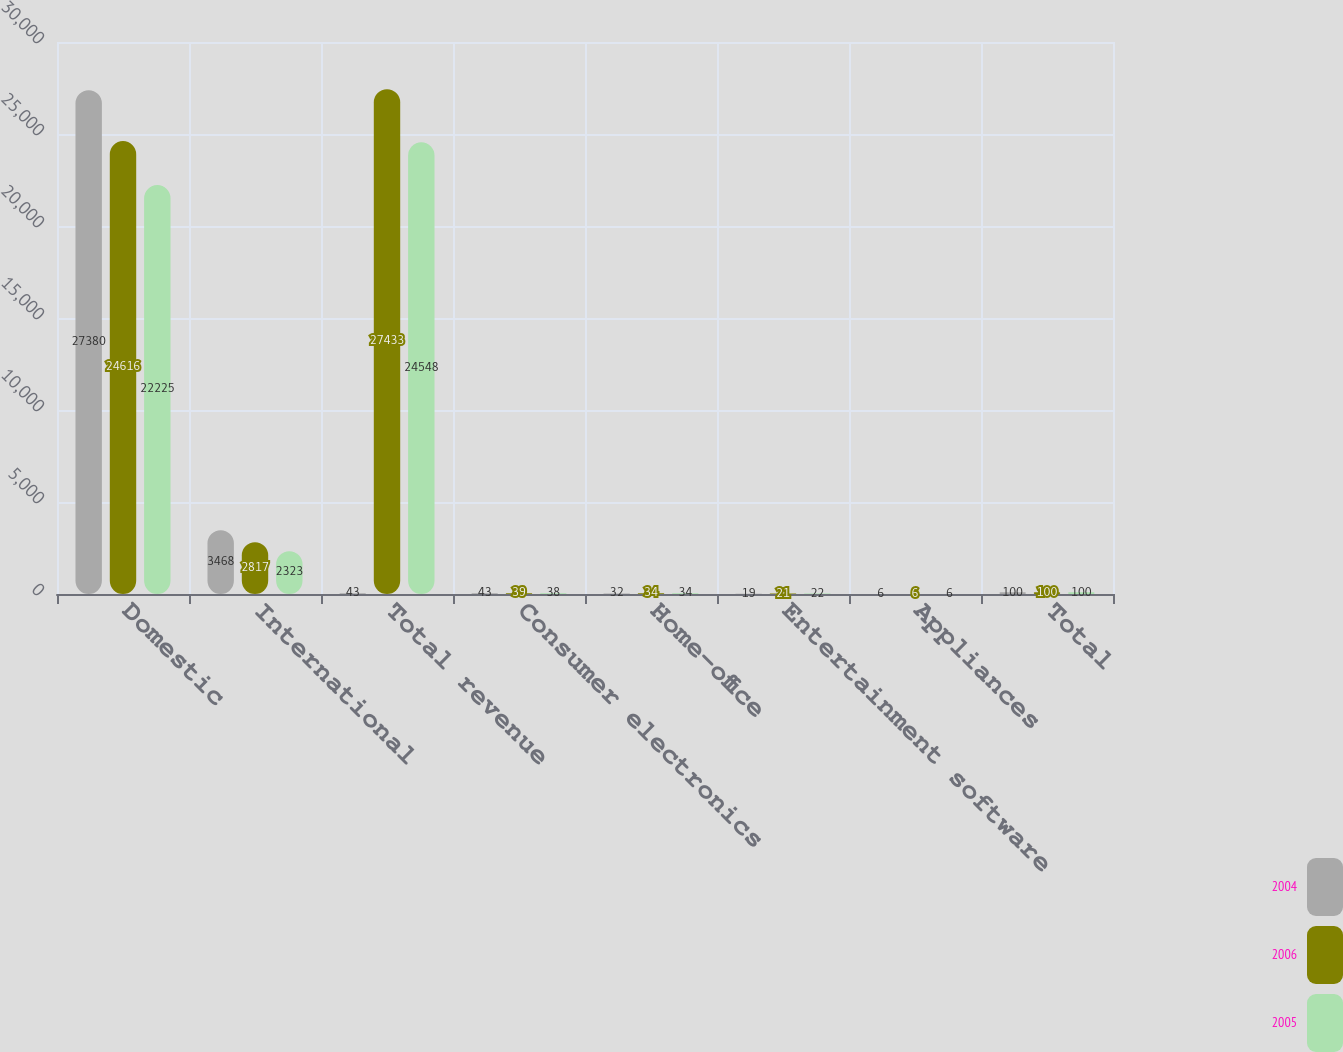Convert chart. <chart><loc_0><loc_0><loc_500><loc_500><stacked_bar_chart><ecel><fcel>Domestic<fcel>International<fcel>Total revenue<fcel>Consumer electronics<fcel>Home-office<fcel>Entertainment software<fcel>Appliances<fcel>Total<nl><fcel>2004<fcel>27380<fcel>3468<fcel>43<fcel>43<fcel>32<fcel>19<fcel>6<fcel>100<nl><fcel>2006<fcel>24616<fcel>2817<fcel>27433<fcel>39<fcel>34<fcel>21<fcel>6<fcel>100<nl><fcel>2005<fcel>22225<fcel>2323<fcel>24548<fcel>38<fcel>34<fcel>22<fcel>6<fcel>100<nl></chart> 